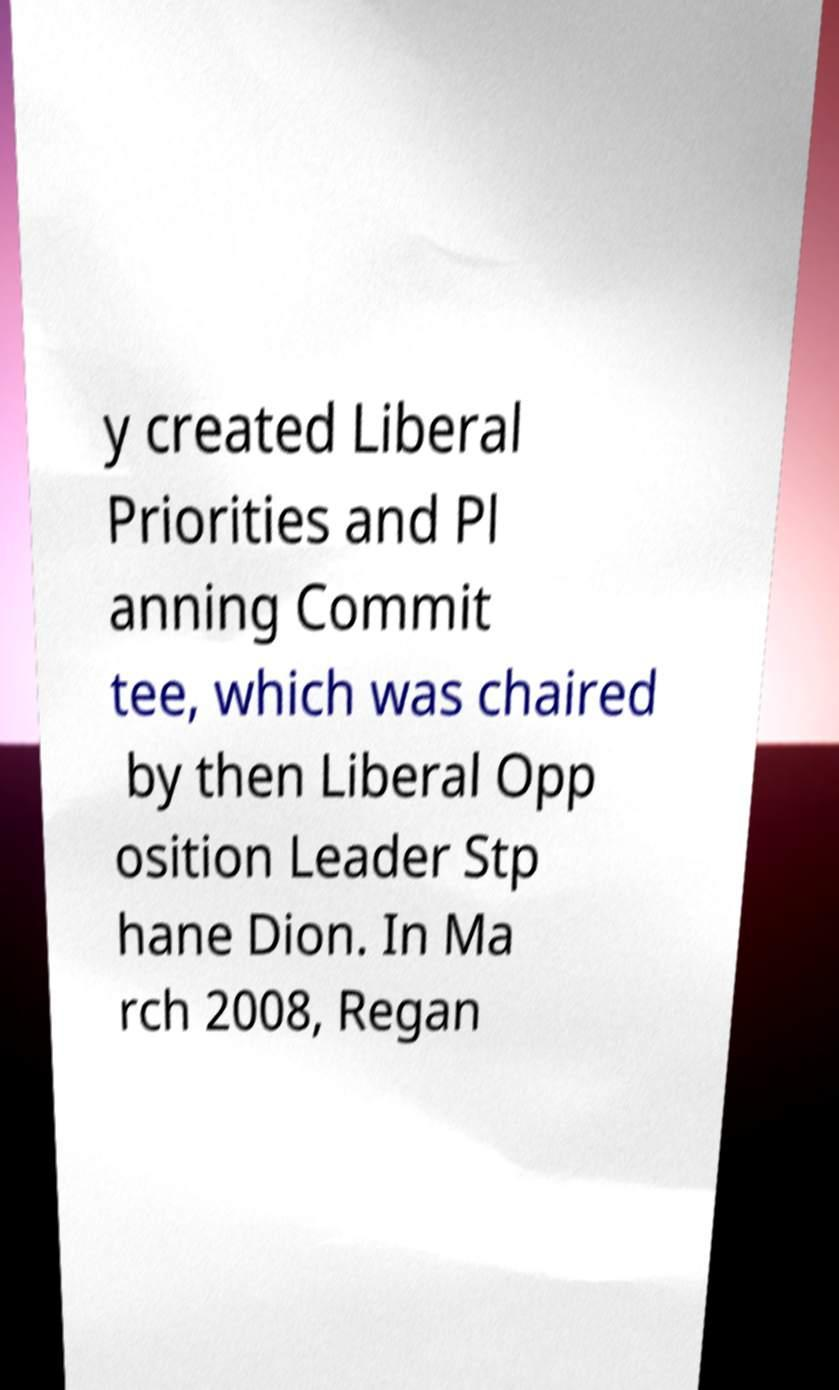Can you read and provide the text displayed in the image?This photo seems to have some interesting text. Can you extract and type it out for me? y created Liberal Priorities and Pl anning Commit tee, which was chaired by then Liberal Opp osition Leader Stp hane Dion. In Ma rch 2008, Regan 